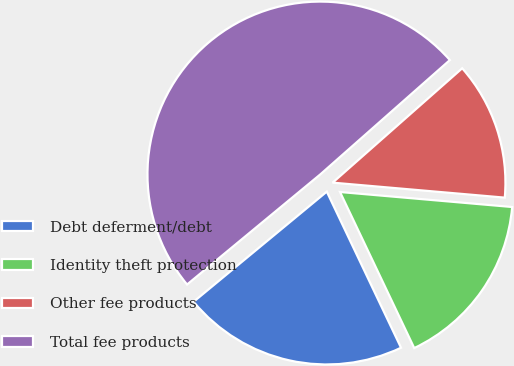Convert chart to OTSL. <chart><loc_0><loc_0><loc_500><loc_500><pie_chart><fcel>Debt deferment/debt<fcel>Identity theft protection<fcel>Other fee products<fcel>Total fee products<nl><fcel>21.07%<fcel>16.55%<fcel>12.89%<fcel>49.48%<nl></chart> 